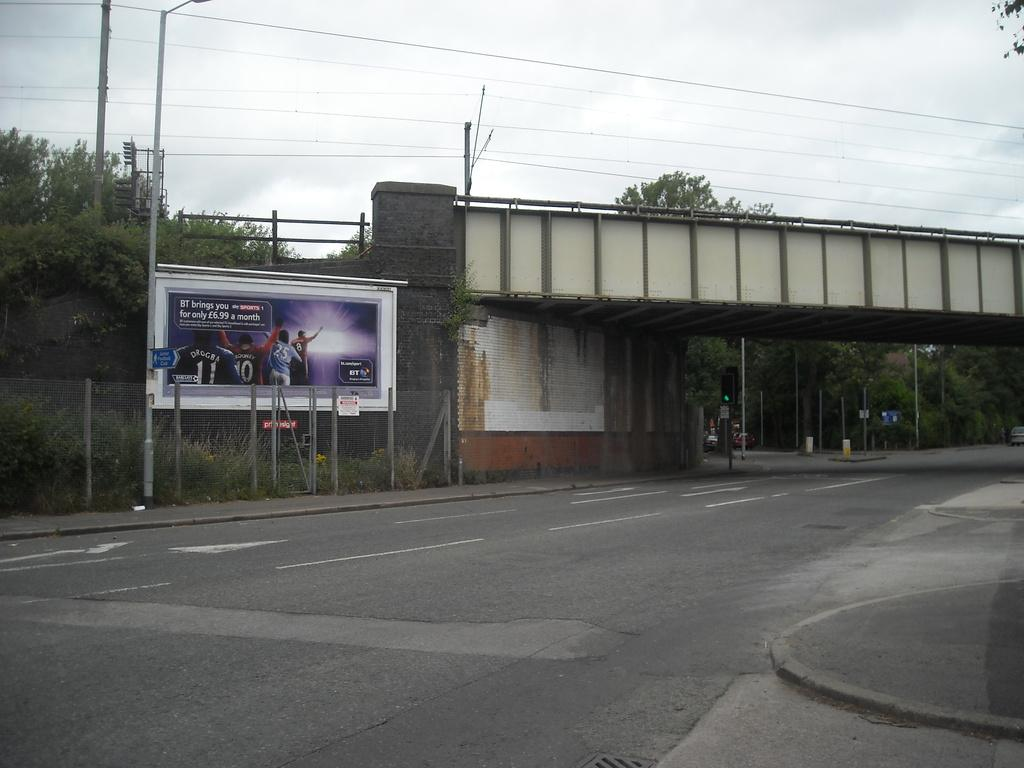What type of structures can be seen in the image? There are boards, a fence, poles, and a bridge in the image. What other elements are present in the image? There are lights, plants, trees, and cables in the image. What can be seen in the background of the image? The sky is visible in the background of the image. What type of room is visible in the image? There is no room present in the image; it features outdoor structures and elements. How does the image demonstrate respect for the environment? The image itself does not demonstrate respect for the environment, as it is a static representation of structures and elements. 